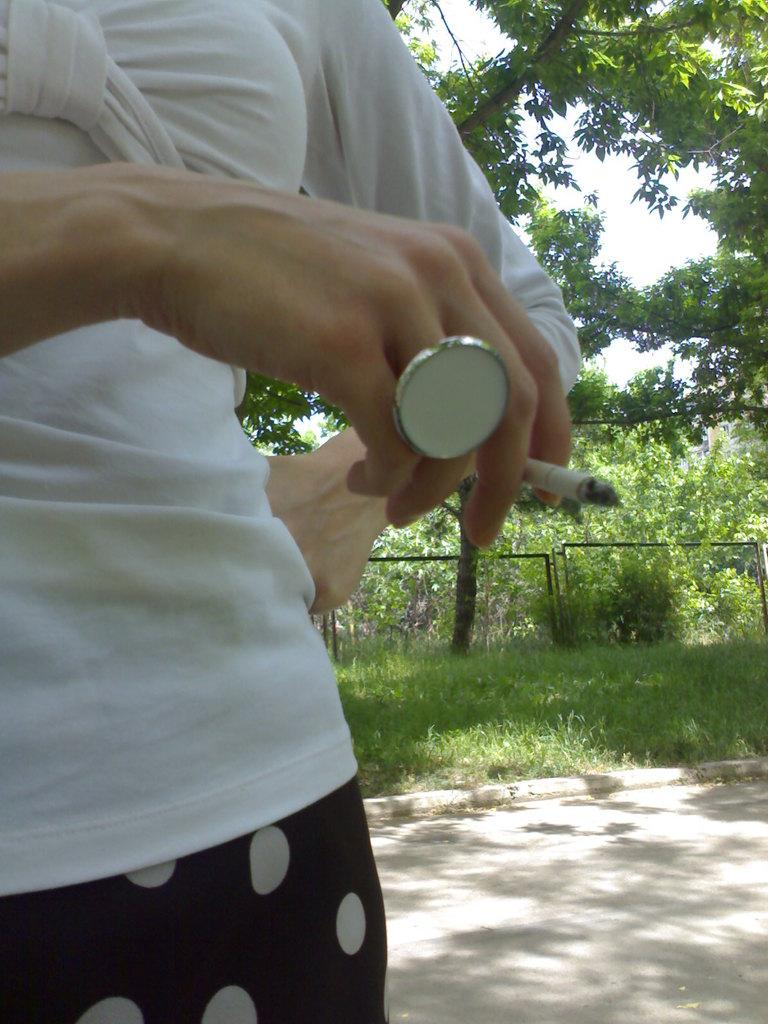What is the person in the image doing? The person is holding a cigarette. Where is the person located in the image? The person is standing on a path. What type of vegetation can be seen in the image? There is grass visible in the image. What can be seen in the background of the image? There are roads, trees, and the sky visible in the background of the image. What type of pleasure can be seen in the image? There is no specific pleasure depicted in the image; it simply shows a person holding a cigarette while standing on a path. What scientific discovery is being made in the image? There is no scientific discovery being made in the image; it is a simple scene of a person standing on a path. 